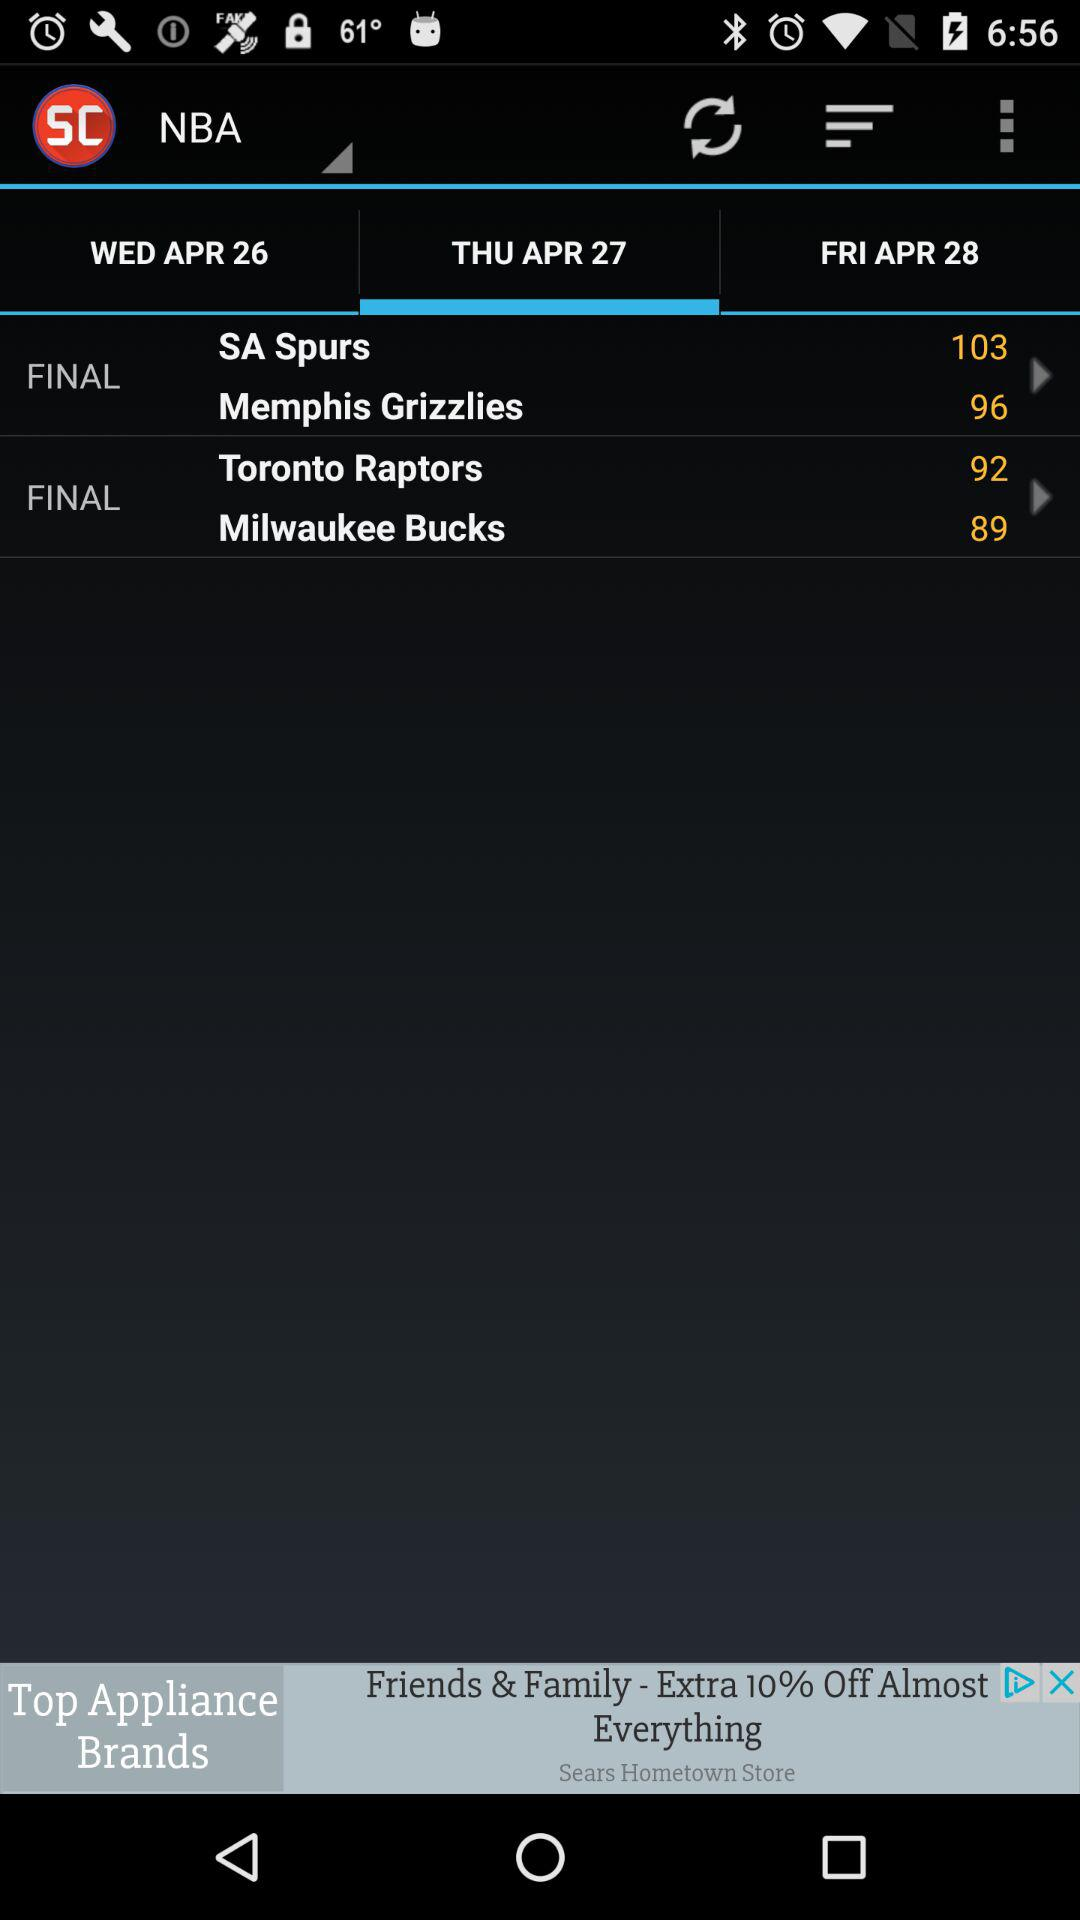Which date is selected for the finals between the "SA Spurs" and the "Memphis Grizzlies"? The selected date is Thursday, April 27. 